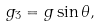<formula> <loc_0><loc_0><loc_500><loc_500>g _ { 3 } = g \sin \theta ,</formula> 